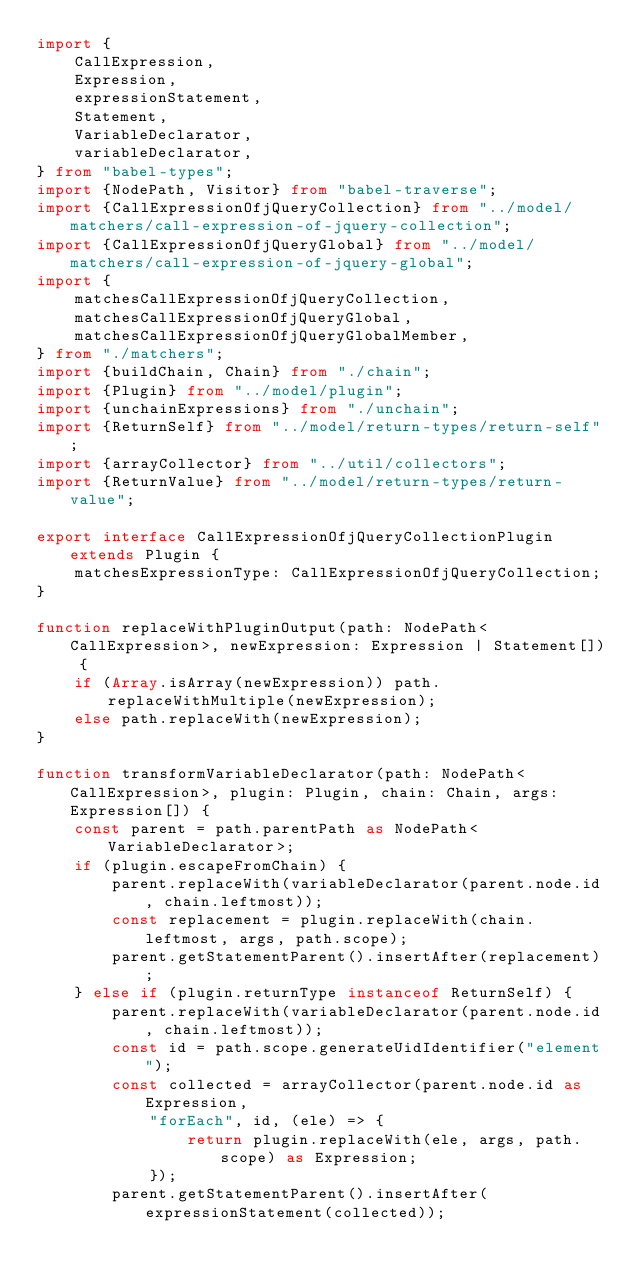<code> <loc_0><loc_0><loc_500><loc_500><_TypeScript_>import {
    CallExpression,
    Expression,
    expressionStatement,
    Statement,
    VariableDeclarator,
    variableDeclarator,
} from "babel-types";
import {NodePath, Visitor} from "babel-traverse";
import {CallExpressionOfjQueryCollection} from "../model/matchers/call-expression-of-jquery-collection";
import {CallExpressionOfjQueryGlobal} from "../model/matchers/call-expression-of-jquery-global";
import {
    matchesCallExpressionOfjQueryCollection,
    matchesCallExpressionOfjQueryGlobal,
    matchesCallExpressionOfjQueryGlobalMember,
} from "./matchers";
import {buildChain, Chain} from "./chain";
import {Plugin} from "../model/plugin";
import {unchainExpressions} from "./unchain";
import {ReturnSelf} from "../model/return-types/return-self";
import {arrayCollector} from "../util/collectors";
import {ReturnValue} from "../model/return-types/return-value";

export interface CallExpressionOfjQueryCollectionPlugin extends Plugin {
    matchesExpressionType: CallExpressionOfjQueryCollection;
}

function replaceWithPluginOutput(path: NodePath<CallExpression>, newExpression: Expression | Statement[]) {
    if (Array.isArray(newExpression)) path.replaceWithMultiple(newExpression);
    else path.replaceWith(newExpression);
}

function transformVariableDeclarator(path: NodePath<CallExpression>, plugin: Plugin, chain: Chain, args: Expression[]) {
    const parent = path.parentPath as NodePath<VariableDeclarator>;
    if (plugin.escapeFromChain) {
        parent.replaceWith(variableDeclarator(parent.node.id, chain.leftmost));
        const replacement = plugin.replaceWith(chain.leftmost, args, path.scope);
        parent.getStatementParent().insertAfter(replacement);
    } else if (plugin.returnType instanceof ReturnSelf) {
        parent.replaceWith(variableDeclarator(parent.node.id, chain.leftmost));
        const id = path.scope.generateUidIdentifier("element");
        const collected = arrayCollector(parent.node.id as Expression,
            "forEach", id, (ele) => {
                return plugin.replaceWith(ele, args, path.scope) as Expression;
            });
        parent.getStatementParent().insertAfter(expressionStatement(collected));</code> 